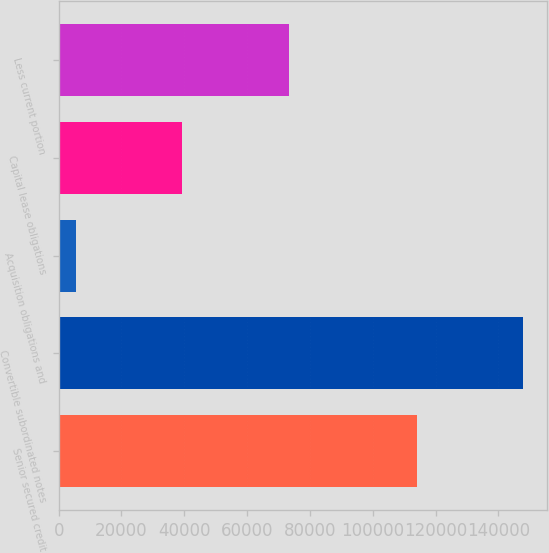Convert chart to OTSL. <chart><loc_0><loc_0><loc_500><loc_500><bar_chart><fcel>Senior secured credit<fcel>Convertible subordinated notes<fcel>Acquisition obligations and<fcel>Capital lease obligations<fcel>Less current portion<nl><fcel>114000<fcel>147954<fcel>5455<fcel>39409.5<fcel>73364<nl></chart> 